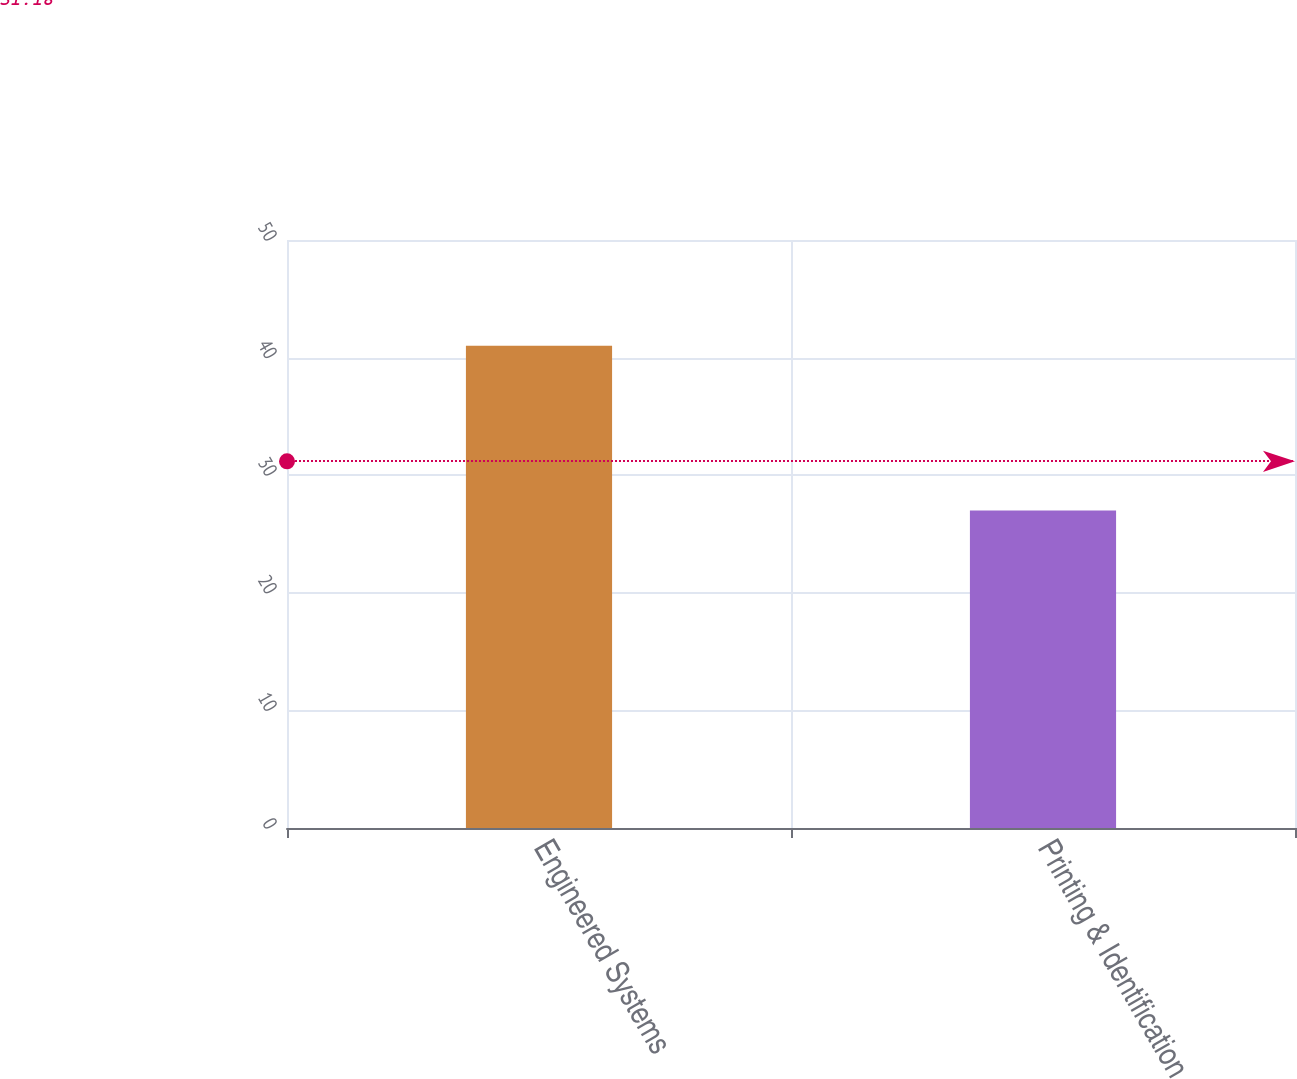Convert chart. <chart><loc_0><loc_0><loc_500><loc_500><bar_chart><fcel>Engineered Systems<fcel>Printing & Identification<nl><fcel>41<fcel>27<nl></chart> 